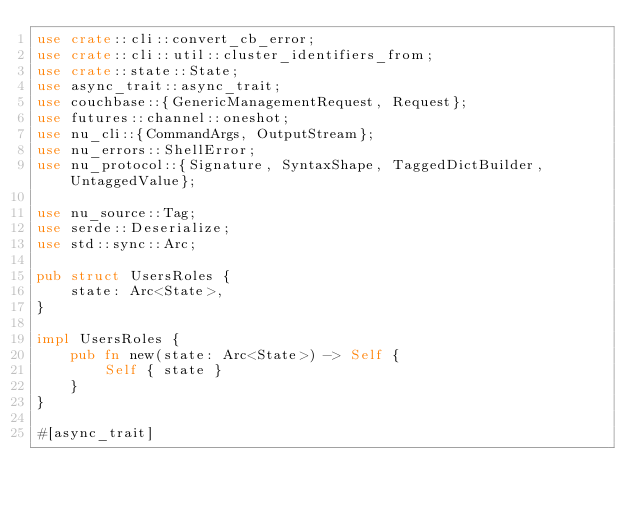<code> <loc_0><loc_0><loc_500><loc_500><_Rust_>use crate::cli::convert_cb_error;
use crate::cli::util::cluster_identifiers_from;
use crate::state::State;
use async_trait::async_trait;
use couchbase::{GenericManagementRequest, Request};
use futures::channel::oneshot;
use nu_cli::{CommandArgs, OutputStream};
use nu_errors::ShellError;
use nu_protocol::{Signature, SyntaxShape, TaggedDictBuilder, UntaggedValue};

use nu_source::Tag;
use serde::Deserialize;
use std::sync::Arc;

pub struct UsersRoles {
    state: Arc<State>,
}

impl UsersRoles {
    pub fn new(state: Arc<State>) -> Self {
        Self { state }
    }
}

#[async_trait]</code> 